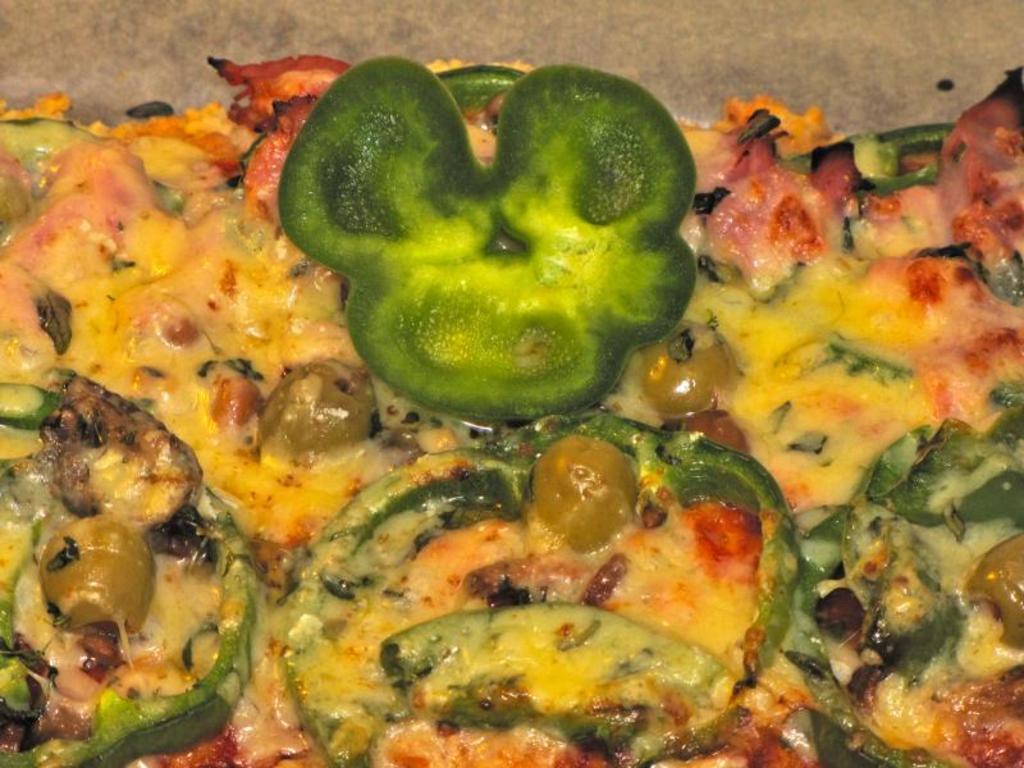In one or two sentences, can you explain what this image depicts? There is a food item with pieces of capsicum and some other items. 